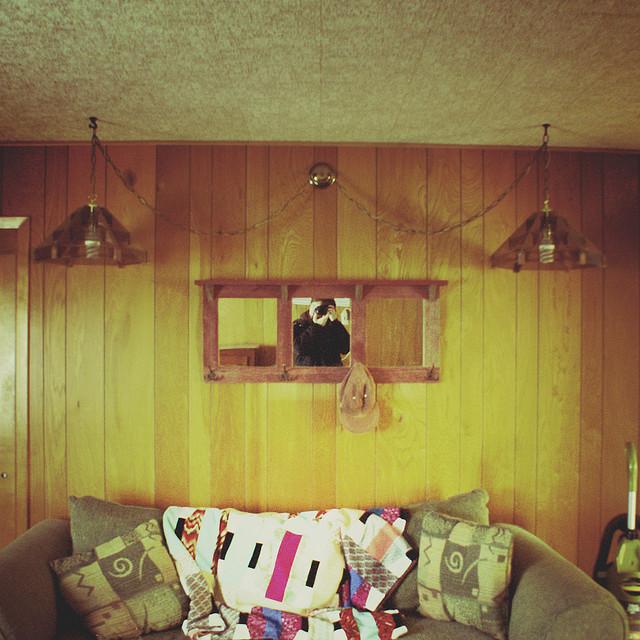Is there a mirror on the wall?
Write a very short answer. Yes. What piece of furniture is this?
Concise answer only. Couch. Is somebody in the mirror?
Be succinct. Yes. 